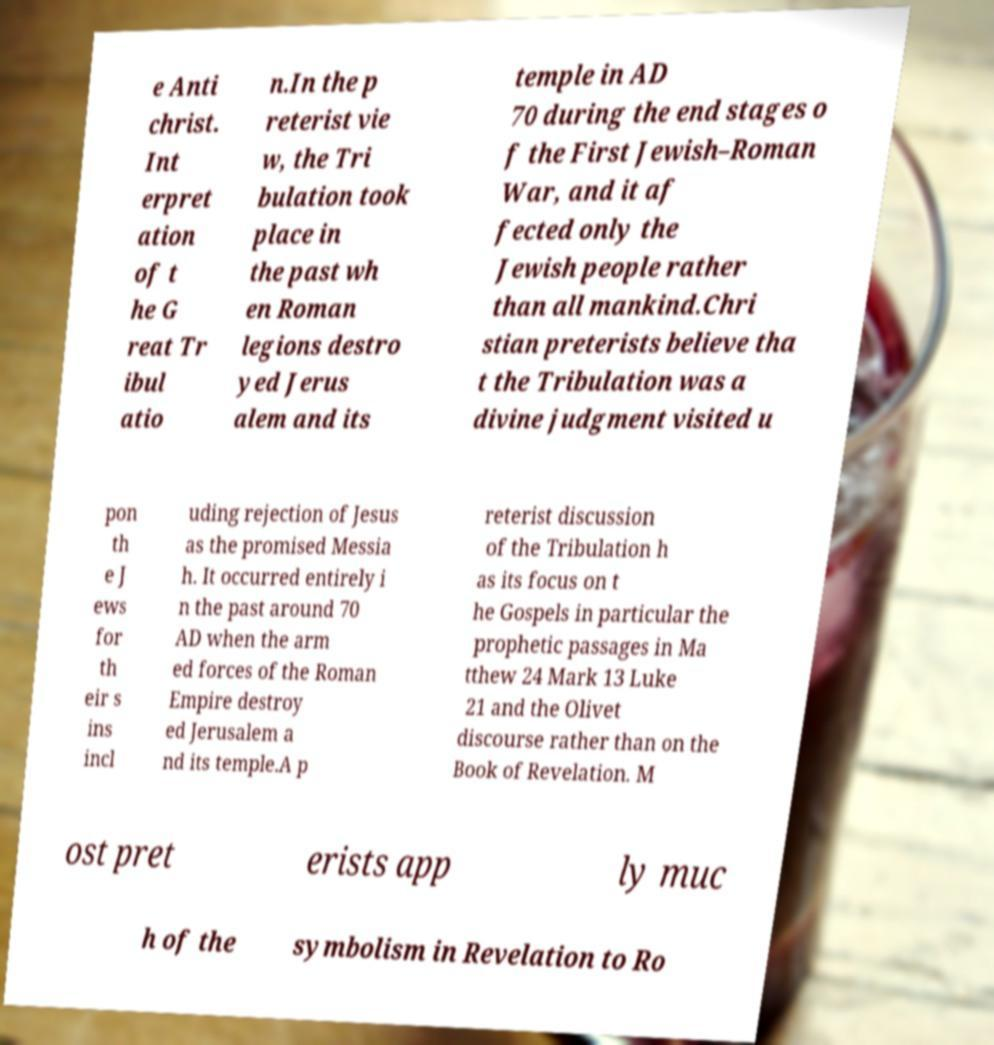Please identify and transcribe the text found in this image. e Anti christ. Int erpret ation of t he G reat Tr ibul atio n.In the p reterist vie w, the Tri bulation took place in the past wh en Roman legions destro yed Jerus alem and its temple in AD 70 during the end stages o f the First Jewish–Roman War, and it af fected only the Jewish people rather than all mankind.Chri stian preterists believe tha t the Tribulation was a divine judgment visited u pon th e J ews for th eir s ins incl uding rejection of Jesus as the promised Messia h. It occurred entirely i n the past around 70 AD when the arm ed forces of the Roman Empire destroy ed Jerusalem a nd its temple.A p reterist discussion of the Tribulation h as its focus on t he Gospels in particular the prophetic passages in Ma tthew 24 Mark 13 Luke 21 and the Olivet discourse rather than on the Book of Revelation. M ost pret erists app ly muc h of the symbolism in Revelation to Ro 